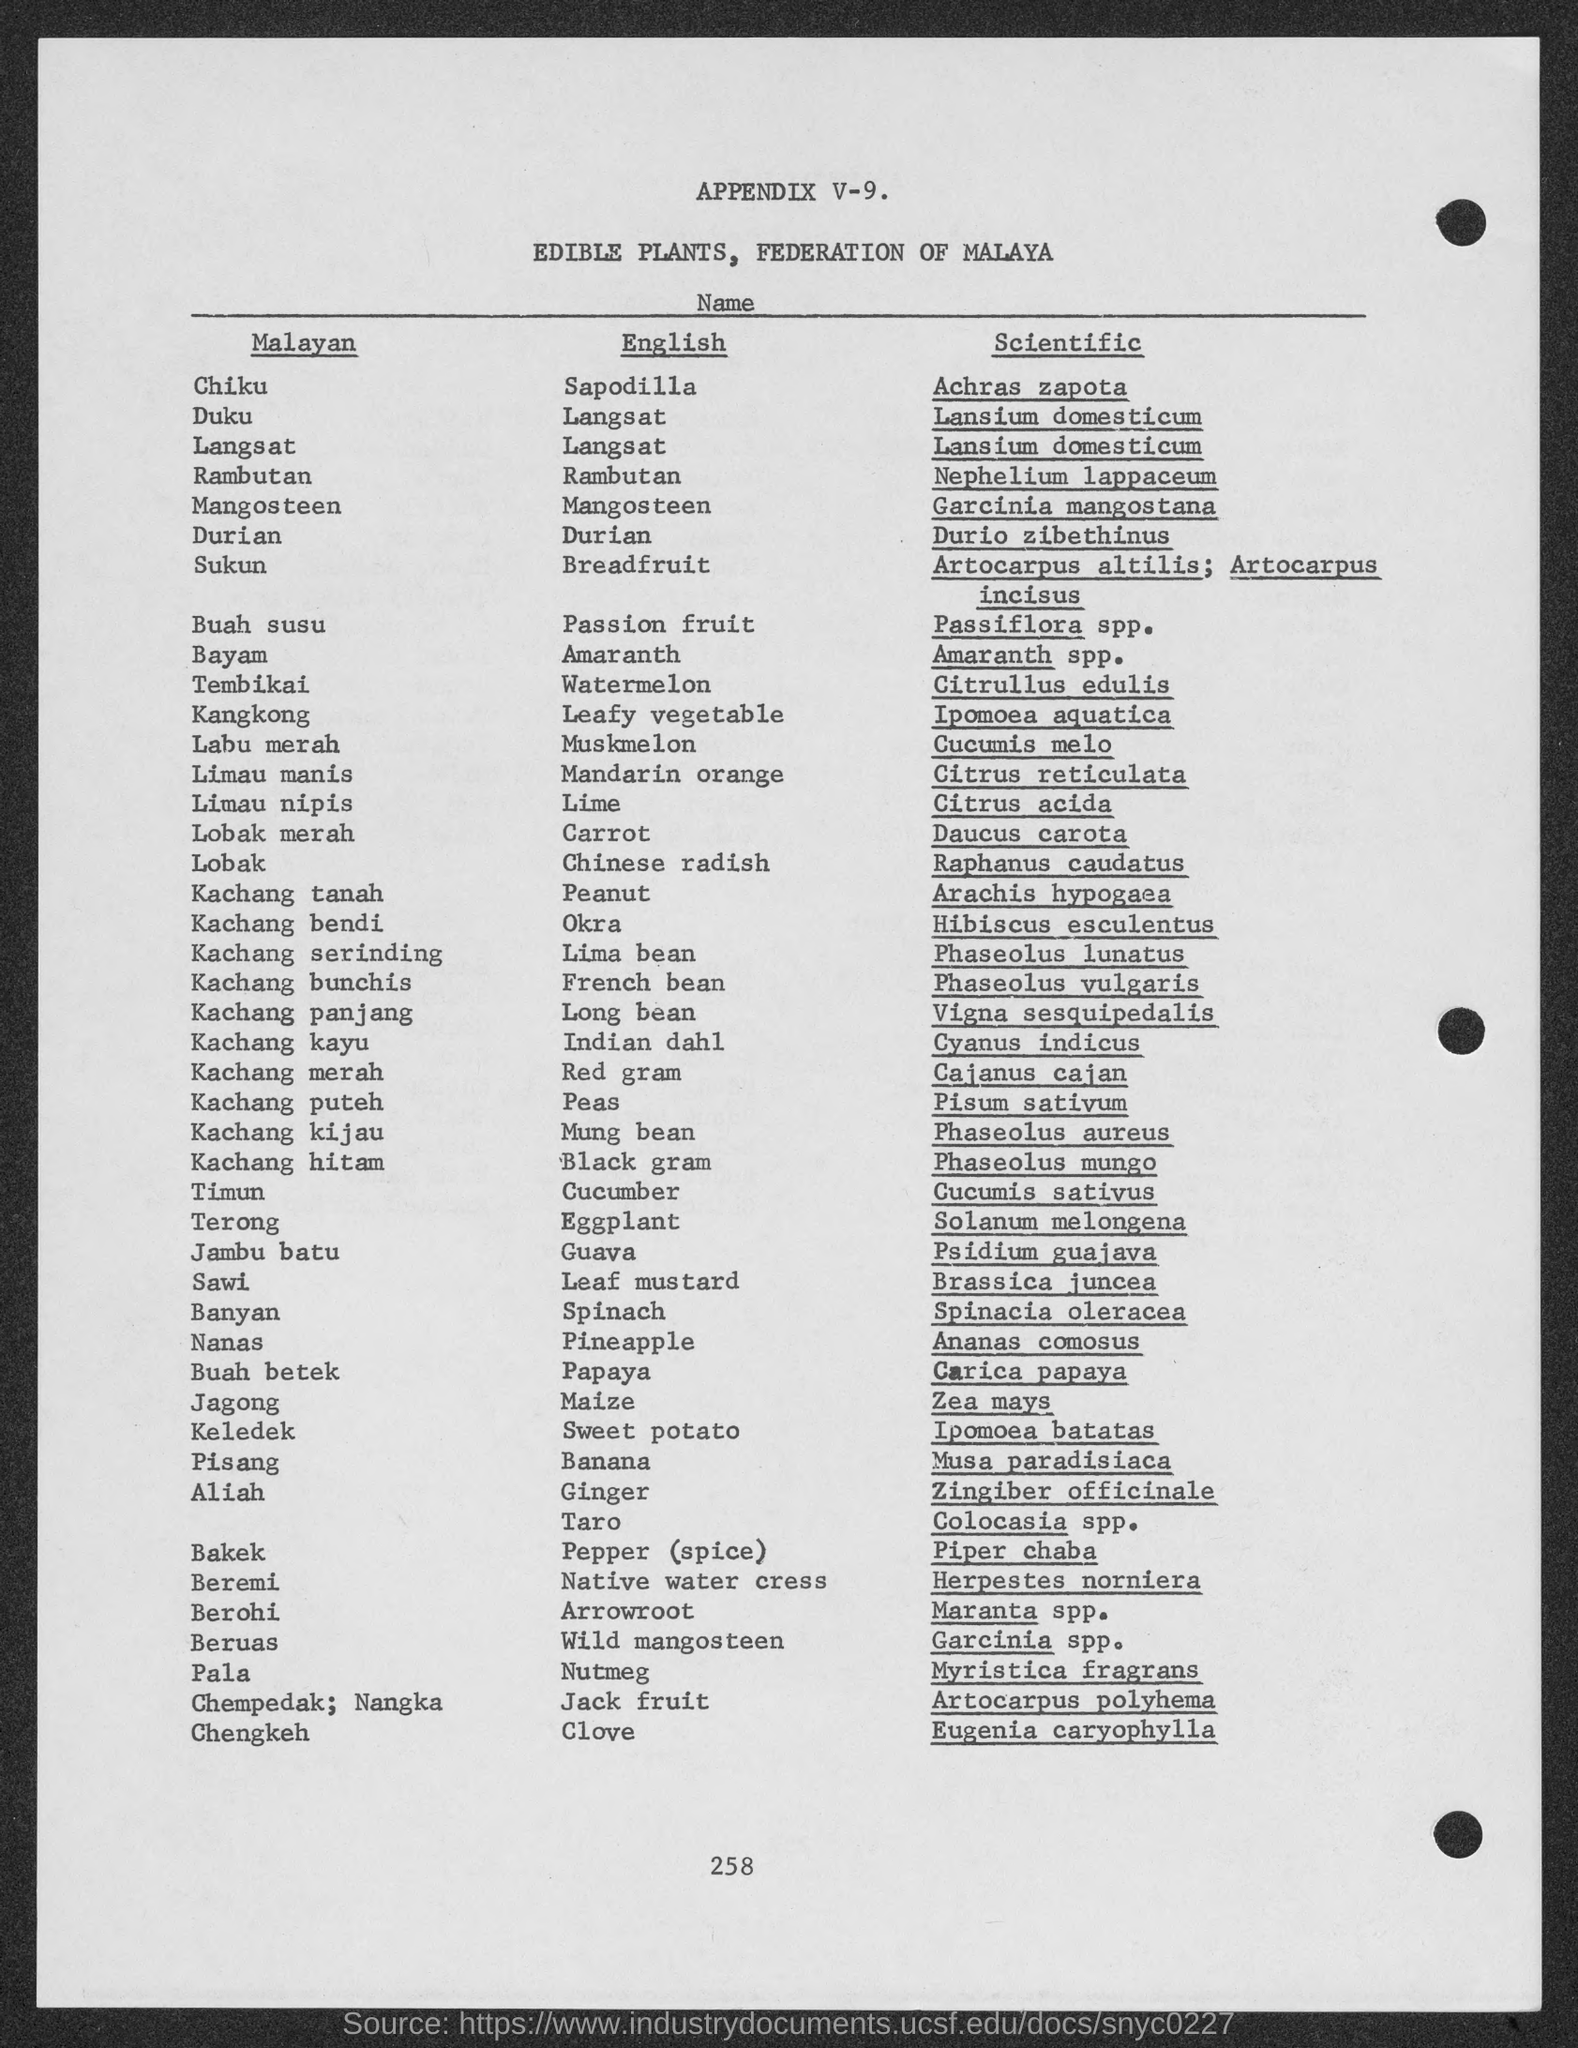What is the English name for Malayan name "Chiku"?
Provide a succinct answer. Sapodilla. What is the English name for Malayan name "Duku"?
Ensure brevity in your answer.  Langsat. What is the English name for Malayan name "Sukun"?
Ensure brevity in your answer.  Breadfruit. What is the English name for Malayan name "Buah susu"?
Ensure brevity in your answer.  Passion Fruit. What is the English name for Malayan name "Bayam"?
Give a very brief answer. Amaranth. What is the English name for Malayan name "Tembikai"?
Ensure brevity in your answer.  Watermelon. What is the English name for Malayan name "Labu merah"?
Make the answer very short. Muskmelon. What is the English name for Malayan name "Lobak merah"?
Provide a succinct answer. Carrot. What is the English name for Malayan name "Timun"?
Provide a short and direct response. Cucumber. What is the English name for Malayan name "Terong"?
Your response must be concise. Eggplant. 